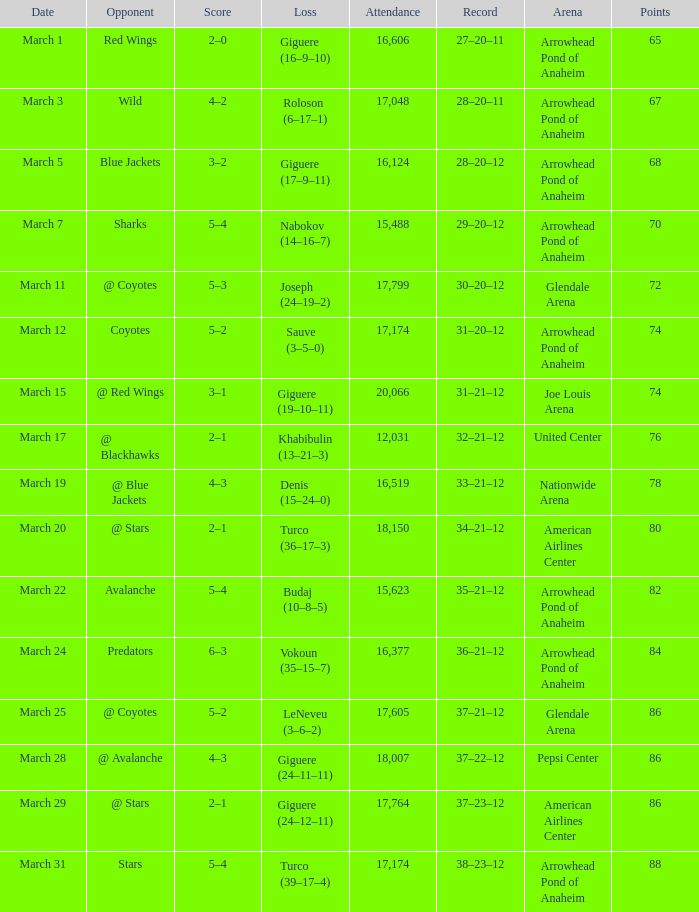What is the number of attendees for the game having a 37-21-12 record and fewer than 86 points? None. 